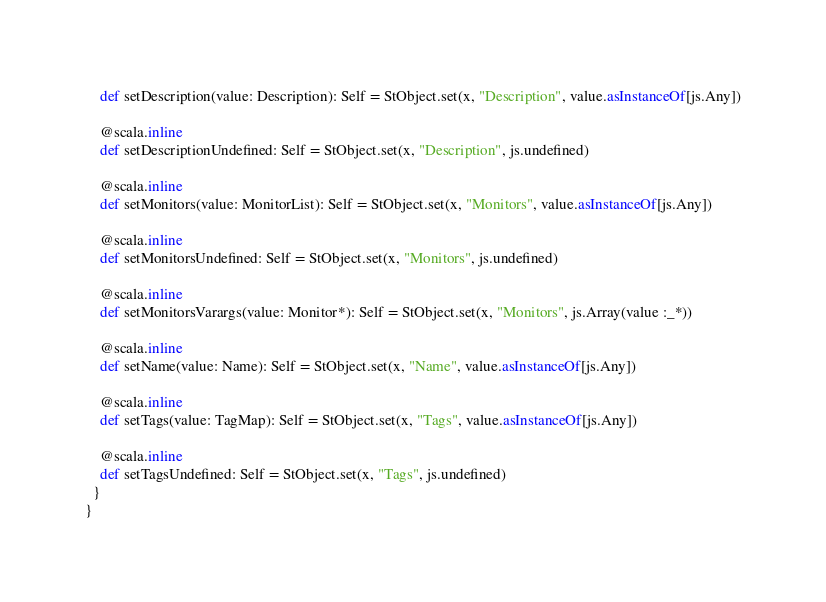Convert code to text. <code><loc_0><loc_0><loc_500><loc_500><_Scala_>    def setDescription(value: Description): Self = StObject.set(x, "Description", value.asInstanceOf[js.Any])
    
    @scala.inline
    def setDescriptionUndefined: Self = StObject.set(x, "Description", js.undefined)
    
    @scala.inline
    def setMonitors(value: MonitorList): Self = StObject.set(x, "Monitors", value.asInstanceOf[js.Any])
    
    @scala.inline
    def setMonitorsUndefined: Self = StObject.set(x, "Monitors", js.undefined)
    
    @scala.inline
    def setMonitorsVarargs(value: Monitor*): Self = StObject.set(x, "Monitors", js.Array(value :_*))
    
    @scala.inline
    def setName(value: Name): Self = StObject.set(x, "Name", value.asInstanceOf[js.Any])
    
    @scala.inline
    def setTags(value: TagMap): Self = StObject.set(x, "Tags", value.asInstanceOf[js.Any])
    
    @scala.inline
    def setTagsUndefined: Self = StObject.set(x, "Tags", js.undefined)
  }
}
</code> 